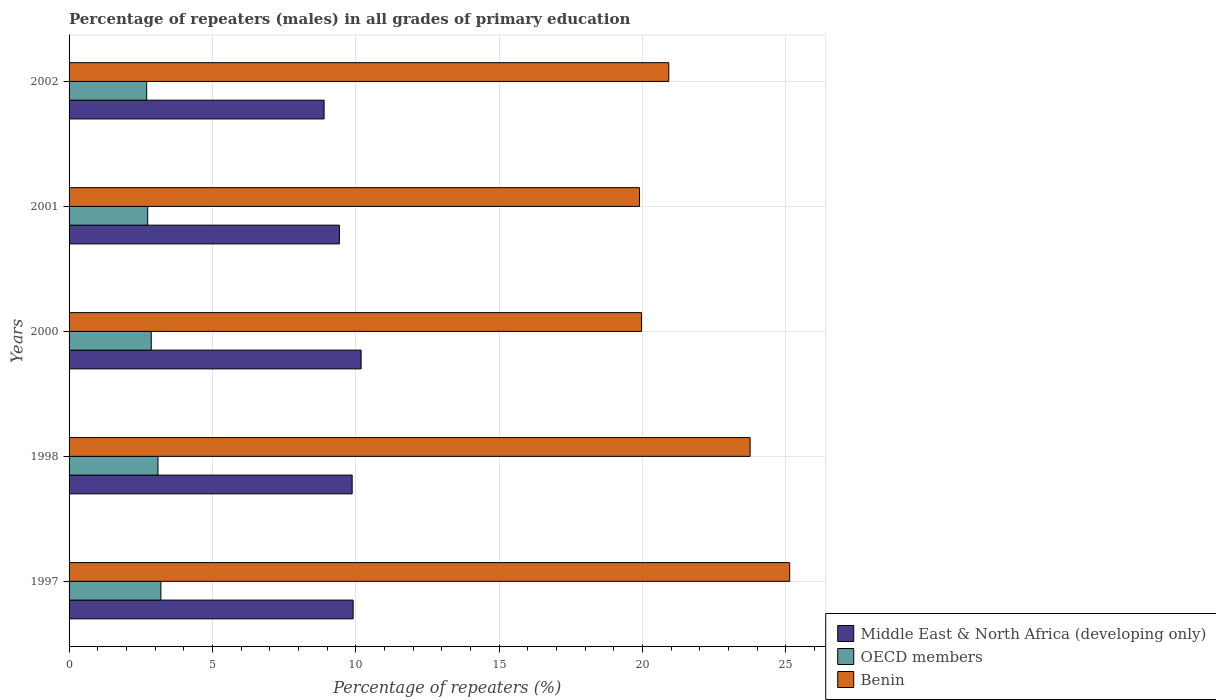Are the number of bars per tick equal to the number of legend labels?
Provide a short and direct response. Yes. How many bars are there on the 4th tick from the bottom?
Your response must be concise. 3. What is the percentage of repeaters (males) in Middle East & North Africa (developing only) in 2002?
Your answer should be compact. 8.9. Across all years, what is the maximum percentage of repeaters (males) in OECD members?
Give a very brief answer. 3.2. Across all years, what is the minimum percentage of repeaters (males) in Middle East & North Africa (developing only)?
Give a very brief answer. 8.9. What is the total percentage of repeaters (males) in Middle East & North Africa (developing only) in the graph?
Your answer should be very brief. 48.3. What is the difference between the percentage of repeaters (males) in Benin in 1998 and that in 2001?
Offer a very short reply. 3.86. What is the difference between the percentage of repeaters (males) in OECD members in 1998 and the percentage of repeaters (males) in Middle East & North Africa (developing only) in 2002?
Your answer should be very brief. -5.8. What is the average percentage of repeaters (males) in Benin per year?
Offer a very short reply. 21.94. In the year 2000, what is the difference between the percentage of repeaters (males) in Middle East & North Africa (developing only) and percentage of repeaters (males) in OECD members?
Your answer should be compact. 7.32. In how many years, is the percentage of repeaters (males) in OECD members greater than 14 %?
Give a very brief answer. 0. What is the ratio of the percentage of repeaters (males) in Benin in 1998 to that in 2002?
Your answer should be very brief. 1.14. Is the percentage of repeaters (males) in Benin in 1997 less than that in 1998?
Keep it short and to the point. No. What is the difference between the highest and the second highest percentage of repeaters (males) in OECD members?
Your response must be concise. 0.1. What is the difference between the highest and the lowest percentage of repeaters (males) in OECD members?
Give a very brief answer. 0.5. What does the 1st bar from the bottom in 1997 represents?
Your response must be concise. Middle East & North Africa (developing only). How many years are there in the graph?
Provide a short and direct response. 5. Does the graph contain any zero values?
Offer a terse response. No. Does the graph contain grids?
Ensure brevity in your answer.  Yes. Where does the legend appear in the graph?
Provide a succinct answer. Bottom right. How many legend labels are there?
Keep it short and to the point. 3. How are the legend labels stacked?
Provide a succinct answer. Vertical. What is the title of the graph?
Ensure brevity in your answer.  Percentage of repeaters (males) in all grades of primary education. Does "Guatemala" appear as one of the legend labels in the graph?
Provide a short and direct response. No. What is the label or title of the X-axis?
Your answer should be very brief. Percentage of repeaters (%). What is the label or title of the Y-axis?
Your answer should be very brief. Years. What is the Percentage of repeaters (%) of Middle East & North Africa (developing only) in 1997?
Give a very brief answer. 9.91. What is the Percentage of repeaters (%) in OECD members in 1997?
Make the answer very short. 3.2. What is the Percentage of repeaters (%) of Benin in 1997?
Offer a terse response. 25.14. What is the Percentage of repeaters (%) of Middle East & North Africa (developing only) in 1998?
Ensure brevity in your answer.  9.88. What is the Percentage of repeaters (%) in OECD members in 1998?
Your answer should be compact. 3.1. What is the Percentage of repeaters (%) of Benin in 1998?
Give a very brief answer. 23.76. What is the Percentage of repeaters (%) in Middle East & North Africa (developing only) in 2000?
Provide a succinct answer. 10.19. What is the Percentage of repeaters (%) of OECD members in 2000?
Offer a very short reply. 2.87. What is the Percentage of repeaters (%) in Benin in 2000?
Provide a succinct answer. 19.97. What is the Percentage of repeaters (%) in Middle East & North Africa (developing only) in 2001?
Your answer should be very brief. 9.43. What is the Percentage of repeaters (%) of OECD members in 2001?
Your answer should be very brief. 2.74. What is the Percentage of repeaters (%) of Benin in 2001?
Your response must be concise. 19.9. What is the Percentage of repeaters (%) in Middle East & North Africa (developing only) in 2002?
Your response must be concise. 8.9. What is the Percentage of repeaters (%) of OECD members in 2002?
Offer a terse response. 2.71. What is the Percentage of repeaters (%) in Benin in 2002?
Offer a very short reply. 20.92. Across all years, what is the maximum Percentage of repeaters (%) in Middle East & North Africa (developing only)?
Ensure brevity in your answer.  10.19. Across all years, what is the maximum Percentage of repeaters (%) of OECD members?
Offer a terse response. 3.2. Across all years, what is the maximum Percentage of repeaters (%) in Benin?
Provide a succinct answer. 25.14. Across all years, what is the minimum Percentage of repeaters (%) of Middle East & North Africa (developing only)?
Give a very brief answer. 8.9. Across all years, what is the minimum Percentage of repeaters (%) of OECD members?
Keep it short and to the point. 2.71. Across all years, what is the minimum Percentage of repeaters (%) of Benin?
Provide a succinct answer. 19.9. What is the total Percentage of repeaters (%) of Middle East & North Africa (developing only) in the graph?
Make the answer very short. 48.3. What is the total Percentage of repeaters (%) of OECD members in the graph?
Your answer should be very brief. 14.62. What is the total Percentage of repeaters (%) of Benin in the graph?
Keep it short and to the point. 109.69. What is the difference between the Percentage of repeaters (%) of Middle East & North Africa (developing only) in 1997 and that in 1998?
Your response must be concise. 0.03. What is the difference between the Percentage of repeaters (%) in OECD members in 1997 and that in 1998?
Provide a short and direct response. 0.1. What is the difference between the Percentage of repeaters (%) of Benin in 1997 and that in 1998?
Ensure brevity in your answer.  1.38. What is the difference between the Percentage of repeaters (%) in Middle East & North Africa (developing only) in 1997 and that in 2000?
Keep it short and to the point. -0.28. What is the difference between the Percentage of repeaters (%) in OECD members in 1997 and that in 2000?
Your answer should be very brief. 0.34. What is the difference between the Percentage of repeaters (%) in Benin in 1997 and that in 2000?
Give a very brief answer. 5.17. What is the difference between the Percentage of repeaters (%) of Middle East & North Africa (developing only) in 1997 and that in 2001?
Offer a terse response. 0.48. What is the difference between the Percentage of repeaters (%) in OECD members in 1997 and that in 2001?
Provide a short and direct response. 0.46. What is the difference between the Percentage of repeaters (%) in Benin in 1997 and that in 2001?
Offer a terse response. 5.24. What is the difference between the Percentage of repeaters (%) in Middle East & North Africa (developing only) in 1997 and that in 2002?
Your answer should be very brief. 1.01. What is the difference between the Percentage of repeaters (%) of OECD members in 1997 and that in 2002?
Offer a very short reply. 0.5. What is the difference between the Percentage of repeaters (%) of Benin in 1997 and that in 2002?
Your response must be concise. 4.22. What is the difference between the Percentage of repeaters (%) in Middle East & North Africa (developing only) in 1998 and that in 2000?
Make the answer very short. -0.31. What is the difference between the Percentage of repeaters (%) of OECD members in 1998 and that in 2000?
Offer a terse response. 0.23. What is the difference between the Percentage of repeaters (%) of Benin in 1998 and that in 2000?
Offer a very short reply. 3.79. What is the difference between the Percentage of repeaters (%) in Middle East & North Africa (developing only) in 1998 and that in 2001?
Make the answer very short. 0.44. What is the difference between the Percentage of repeaters (%) in OECD members in 1998 and that in 2001?
Provide a succinct answer. 0.36. What is the difference between the Percentage of repeaters (%) of Benin in 1998 and that in 2001?
Give a very brief answer. 3.86. What is the difference between the Percentage of repeaters (%) in Middle East & North Africa (developing only) in 1998 and that in 2002?
Offer a terse response. 0.98. What is the difference between the Percentage of repeaters (%) of OECD members in 1998 and that in 2002?
Provide a short and direct response. 0.39. What is the difference between the Percentage of repeaters (%) of Benin in 1998 and that in 2002?
Provide a succinct answer. 2.84. What is the difference between the Percentage of repeaters (%) in Middle East & North Africa (developing only) in 2000 and that in 2001?
Give a very brief answer. 0.76. What is the difference between the Percentage of repeaters (%) in OECD members in 2000 and that in 2001?
Make the answer very short. 0.12. What is the difference between the Percentage of repeaters (%) of Benin in 2000 and that in 2001?
Ensure brevity in your answer.  0.07. What is the difference between the Percentage of repeaters (%) of Middle East & North Africa (developing only) in 2000 and that in 2002?
Your answer should be very brief. 1.29. What is the difference between the Percentage of repeaters (%) in OECD members in 2000 and that in 2002?
Provide a succinct answer. 0.16. What is the difference between the Percentage of repeaters (%) in Benin in 2000 and that in 2002?
Provide a succinct answer. -0.95. What is the difference between the Percentage of repeaters (%) of Middle East & North Africa (developing only) in 2001 and that in 2002?
Make the answer very short. 0.53. What is the difference between the Percentage of repeaters (%) in OECD members in 2001 and that in 2002?
Your answer should be compact. 0.04. What is the difference between the Percentage of repeaters (%) in Benin in 2001 and that in 2002?
Ensure brevity in your answer.  -1.02. What is the difference between the Percentage of repeaters (%) in Middle East & North Africa (developing only) in 1997 and the Percentage of repeaters (%) in OECD members in 1998?
Give a very brief answer. 6.81. What is the difference between the Percentage of repeaters (%) in Middle East & North Africa (developing only) in 1997 and the Percentage of repeaters (%) in Benin in 1998?
Give a very brief answer. -13.85. What is the difference between the Percentage of repeaters (%) in OECD members in 1997 and the Percentage of repeaters (%) in Benin in 1998?
Make the answer very short. -20.56. What is the difference between the Percentage of repeaters (%) of Middle East & North Africa (developing only) in 1997 and the Percentage of repeaters (%) of OECD members in 2000?
Offer a terse response. 7.04. What is the difference between the Percentage of repeaters (%) in Middle East & North Africa (developing only) in 1997 and the Percentage of repeaters (%) in Benin in 2000?
Your response must be concise. -10.06. What is the difference between the Percentage of repeaters (%) in OECD members in 1997 and the Percentage of repeaters (%) in Benin in 2000?
Offer a terse response. -16.77. What is the difference between the Percentage of repeaters (%) of Middle East & North Africa (developing only) in 1997 and the Percentage of repeaters (%) of OECD members in 2001?
Ensure brevity in your answer.  7.17. What is the difference between the Percentage of repeaters (%) of Middle East & North Africa (developing only) in 1997 and the Percentage of repeaters (%) of Benin in 2001?
Provide a short and direct response. -9.99. What is the difference between the Percentage of repeaters (%) in OECD members in 1997 and the Percentage of repeaters (%) in Benin in 2001?
Ensure brevity in your answer.  -16.7. What is the difference between the Percentage of repeaters (%) in Middle East & North Africa (developing only) in 1997 and the Percentage of repeaters (%) in OECD members in 2002?
Your response must be concise. 7.2. What is the difference between the Percentage of repeaters (%) in Middle East & North Africa (developing only) in 1997 and the Percentage of repeaters (%) in Benin in 2002?
Offer a very short reply. -11.01. What is the difference between the Percentage of repeaters (%) in OECD members in 1997 and the Percentage of repeaters (%) in Benin in 2002?
Keep it short and to the point. -17.72. What is the difference between the Percentage of repeaters (%) of Middle East & North Africa (developing only) in 1998 and the Percentage of repeaters (%) of OECD members in 2000?
Offer a terse response. 7.01. What is the difference between the Percentage of repeaters (%) in Middle East & North Africa (developing only) in 1998 and the Percentage of repeaters (%) in Benin in 2000?
Provide a short and direct response. -10.09. What is the difference between the Percentage of repeaters (%) of OECD members in 1998 and the Percentage of repeaters (%) of Benin in 2000?
Your answer should be very brief. -16.87. What is the difference between the Percentage of repeaters (%) of Middle East & North Africa (developing only) in 1998 and the Percentage of repeaters (%) of OECD members in 2001?
Offer a very short reply. 7.13. What is the difference between the Percentage of repeaters (%) of Middle East & North Africa (developing only) in 1998 and the Percentage of repeaters (%) of Benin in 2001?
Give a very brief answer. -10.03. What is the difference between the Percentage of repeaters (%) in OECD members in 1998 and the Percentage of repeaters (%) in Benin in 2001?
Offer a very short reply. -16.8. What is the difference between the Percentage of repeaters (%) of Middle East & North Africa (developing only) in 1998 and the Percentage of repeaters (%) of OECD members in 2002?
Your response must be concise. 7.17. What is the difference between the Percentage of repeaters (%) in Middle East & North Africa (developing only) in 1998 and the Percentage of repeaters (%) in Benin in 2002?
Offer a very short reply. -11.05. What is the difference between the Percentage of repeaters (%) in OECD members in 1998 and the Percentage of repeaters (%) in Benin in 2002?
Ensure brevity in your answer.  -17.82. What is the difference between the Percentage of repeaters (%) of Middle East & North Africa (developing only) in 2000 and the Percentage of repeaters (%) of OECD members in 2001?
Offer a terse response. 7.45. What is the difference between the Percentage of repeaters (%) of Middle East & North Africa (developing only) in 2000 and the Percentage of repeaters (%) of Benin in 2001?
Offer a terse response. -9.71. What is the difference between the Percentage of repeaters (%) in OECD members in 2000 and the Percentage of repeaters (%) in Benin in 2001?
Your answer should be compact. -17.03. What is the difference between the Percentage of repeaters (%) of Middle East & North Africa (developing only) in 2000 and the Percentage of repeaters (%) of OECD members in 2002?
Keep it short and to the point. 7.48. What is the difference between the Percentage of repeaters (%) in Middle East & North Africa (developing only) in 2000 and the Percentage of repeaters (%) in Benin in 2002?
Ensure brevity in your answer.  -10.73. What is the difference between the Percentage of repeaters (%) in OECD members in 2000 and the Percentage of repeaters (%) in Benin in 2002?
Offer a terse response. -18.05. What is the difference between the Percentage of repeaters (%) in Middle East & North Africa (developing only) in 2001 and the Percentage of repeaters (%) in OECD members in 2002?
Offer a terse response. 6.72. What is the difference between the Percentage of repeaters (%) of Middle East & North Africa (developing only) in 2001 and the Percentage of repeaters (%) of Benin in 2002?
Your answer should be compact. -11.49. What is the difference between the Percentage of repeaters (%) of OECD members in 2001 and the Percentage of repeaters (%) of Benin in 2002?
Give a very brief answer. -18.18. What is the average Percentage of repeaters (%) of Middle East & North Africa (developing only) per year?
Give a very brief answer. 9.66. What is the average Percentage of repeaters (%) in OECD members per year?
Your answer should be compact. 2.92. What is the average Percentage of repeaters (%) in Benin per year?
Offer a very short reply. 21.94. In the year 1997, what is the difference between the Percentage of repeaters (%) in Middle East & North Africa (developing only) and Percentage of repeaters (%) in OECD members?
Make the answer very short. 6.71. In the year 1997, what is the difference between the Percentage of repeaters (%) in Middle East & North Africa (developing only) and Percentage of repeaters (%) in Benin?
Offer a terse response. -15.23. In the year 1997, what is the difference between the Percentage of repeaters (%) in OECD members and Percentage of repeaters (%) in Benin?
Provide a short and direct response. -21.94. In the year 1998, what is the difference between the Percentage of repeaters (%) of Middle East & North Africa (developing only) and Percentage of repeaters (%) of OECD members?
Your response must be concise. 6.77. In the year 1998, what is the difference between the Percentage of repeaters (%) of Middle East & North Africa (developing only) and Percentage of repeaters (%) of Benin?
Keep it short and to the point. -13.88. In the year 1998, what is the difference between the Percentage of repeaters (%) of OECD members and Percentage of repeaters (%) of Benin?
Make the answer very short. -20.66. In the year 2000, what is the difference between the Percentage of repeaters (%) in Middle East & North Africa (developing only) and Percentage of repeaters (%) in OECD members?
Offer a very short reply. 7.32. In the year 2000, what is the difference between the Percentage of repeaters (%) in Middle East & North Africa (developing only) and Percentage of repeaters (%) in Benin?
Keep it short and to the point. -9.78. In the year 2000, what is the difference between the Percentage of repeaters (%) of OECD members and Percentage of repeaters (%) of Benin?
Your answer should be very brief. -17.1. In the year 2001, what is the difference between the Percentage of repeaters (%) in Middle East & North Africa (developing only) and Percentage of repeaters (%) in OECD members?
Your response must be concise. 6.69. In the year 2001, what is the difference between the Percentage of repeaters (%) of Middle East & North Africa (developing only) and Percentage of repeaters (%) of Benin?
Provide a succinct answer. -10.47. In the year 2001, what is the difference between the Percentage of repeaters (%) of OECD members and Percentage of repeaters (%) of Benin?
Provide a short and direct response. -17.16. In the year 2002, what is the difference between the Percentage of repeaters (%) in Middle East & North Africa (developing only) and Percentage of repeaters (%) in OECD members?
Offer a terse response. 6.19. In the year 2002, what is the difference between the Percentage of repeaters (%) in Middle East & North Africa (developing only) and Percentage of repeaters (%) in Benin?
Ensure brevity in your answer.  -12.03. In the year 2002, what is the difference between the Percentage of repeaters (%) of OECD members and Percentage of repeaters (%) of Benin?
Ensure brevity in your answer.  -18.21. What is the ratio of the Percentage of repeaters (%) in Middle East & North Africa (developing only) in 1997 to that in 1998?
Your response must be concise. 1. What is the ratio of the Percentage of repeaters (%) of OECD members in 1997 to that in 1998?
Your answer should be very brief. 1.03. What is the ratio of the Percentage of repeaters (%) of Benin in 1997 to that in 1998?
Provide a succinct answer. 1.06. What is the ratio of the Percentage of repeaters (%) in Middle East & North Africa (developing only) in 1997 to that in 2000?
Keep it short and to the point. 0.97. What is the ratio of the Percentage of repeaters (%) in OECD members in 1997 to that in 2000?
Your response must be concise. 1.12. What is the ratio of the Percentage of repeaters (%) of Benin in 1997 to that in 2000?
Provide a short and direct response. 1.26. What is the ratio of the Percentage of repeaters (%) of Middle East & North Africa (developing only) in 1997 to that in 2001?
Give a very brief answer. 1.05. What is the ratio of the Percentage of repeaters (%) in OECD members in 1997 to that in 2001?
Your answer should be compact. 1.17. What is the ratio of the Percentage of repeaters (%) in Benin in 1997 to that in 2001?
Keep it short and to the point. 1.26. What is the ratio of the Percentage of repeaters (%) of Middle East & North Africa (developing only) in 1997 to that in 2002?
Keep it short and to the point. 1.11. What is the ratio of the Percentage of repeaters (%) in OECD members in 1997 to that in 2002?
Your response must be concise. 1.18. What is the ratio of the Percentage of repeaters (%) in Benin in 1997 to that in 2002?
Keep it short and to the point. 1.2. What is the ratio of the Percentage of repeaters (%) in Middle East & North Africa (developing only) in 1998 to that in 2000?
Your answer should be very brief. 0.97. What is the ratio of the Percentage of repeaters (%) in OECD members in 1998 to that in 2000?
Your answer should be very brief. 1.08. What is the ratio of the Percentage of repeaters (%) of Benin in 1998 to that in 2000?
Make the answer very short. 1.19. What is the ratio of the Percentage of repeaters (%) of Middle East & North Africa (developing only) in 1998 to that in 2001?
Ensure brevity in your answer.  1.05. What is the ratio of the Percentage of repeaters (%) in OECD members in 1998 to that in 2001?
Keep it short and to the point. 1.13. What is the ratio of the Percentage of repeaters (%) of Benin in 1998 to that in 2001?
Provide a short and direct response. 1.19. What is the ratio of the Percentage of repeaters (%) in Middle East & North Africa (developing only) in 1998 to that in 2002?
Your answer should be very brief. 1.11. What is the ratio of the Percentage of repeaters (%) in OECD members in 1998 to that in 2002?
Provide a short and direct response. 1.15. What is the ratio of the Percentage of repeaters (%) of Benin in 1998 to that in 2002?
Ensure brevity in your answer.  1.14. What is the ratio of the Percentage of repeaters (%) in Middle East & North Africa (developing only) in 2000 to that in 2001?
Provide a succinct answer. 1.08. What is the ratio of the Percentage of repeaters (%) of OECD members in 2000 to that in 2001?
Offer a very short reply. 1.05. What is the ratio of the Percentage of repeaters (%) in Benin in 2000 to that in 2001?
Give a very brief answer. 1. What is the ratio of the Percentage of repeaters (%) of Middle East & North Africa (developing only) in 2000 to that in 2002?
Offer a terse response. 1.15. What is the ratio of the Percentage of repeaters (%) of OECD members in 2000 to that in 2002?
Your answer should be compact. 1.06. What is the ratio of the Percentage of repeaters (%) of Benin in 2000 to that in 2002?
Provide a succinct answer. 0.95. What is the ratio of the Percentage of repeaters (%) in Middle East & North Africa (developing only) in 2001 to that in 2002?
Your response must be concise. 1.06. What is the ratio of the Percentage of repeaters (%) of OECD members in 2001 to that in 2002?
Offer a terse response. 1.01. What is the ratio of the Percentage of repeaters (%) of Benin in 2001 to that in 2002?
Your answer should be compact. 0.95. What is the difference between the highest and the second highest Percentage of repeaters (%) in Middle East & North Africa (developing only)?
Keep it short and to the point. 0.28. What is the difference between the highest and the second highest Percentage of repeaters (%) in OECD members?
Keep it short and to the point. 0.1. What is the difference between the highest and the second highest Percentage of repeaters (%) in Benin?
Provide a succinct answer. 1.38. What is the difference between the highest and the lowest Percentage of repeaters (%) of Middle East & North Africa (developing only)?
Your response must be concise. 1.29. What is the difference between the highest and the lowest Percentage of repeaters (%) of OECD members?
Make the answer very short. 0.5. What is the difference between the highest and the lowest Percentage of repeaters (%) in Benin?
Your answer should be compact. 5.24. 